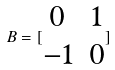<formula> <loc_0><loc_0><loc_500><loc_500>B = [ \begin{matrix} 0 & 1 \\ - 1 & 0 \end{matrix} ]</formula> 